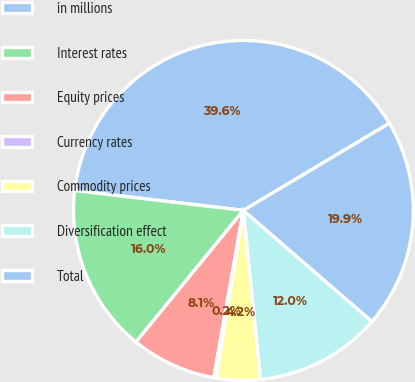Convert chart. <chart><loc_0><loc_0><loc_500><loc_500><pie_chart><fcel>in millions<fcel>Interest rates<fcel>Equity prices<fcel>Currency rates<fcel>Commodity prices<fcel>Diversification effect<fcel>Total<nl><fcel>39.58%<fcel>15.97%<fcel>8.1%<fcel>0.24%<fcel>4.17%<fcel>12.04%<fcel>19.91%<nl></chart> 